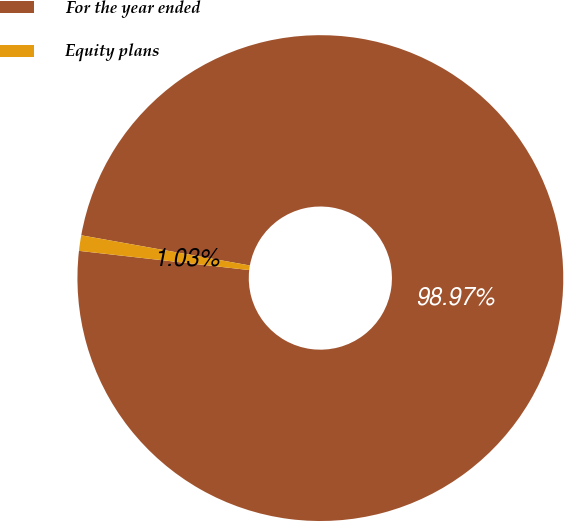Convert chart to OTSL. <chart><loc_0><loc_0><loc_500><loc_500><pie_chart><fcel>For the year ended<fcel>Equity plans<nl><fcel>98.97%<fcel>1.03%<nl></chart> 